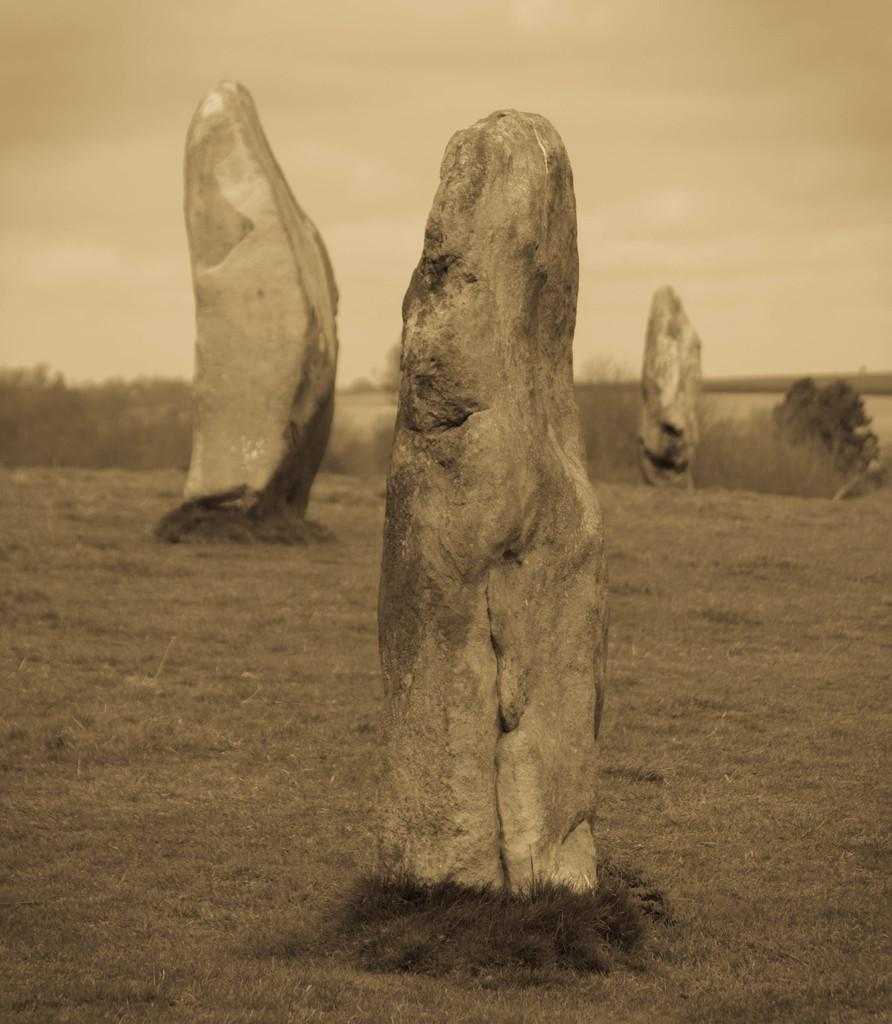What is visible in the center of the image? The sky, clouds, plants, grass, and rocks are visible in the center of the image. Can you describe the natural elements present in the center of the image? The center of the image features clouds, plants, grass, and rocks. What type of terrain is suggested by the presence of grass and rocks in the image? The presence of grass and rocks suggests a natural, outdoor terrain. What type of camp can be seen set up in the center of the image? There is no camp present in the image; it features natural elements such as the sky, clouds, plants, grass, and rocks. What tendency can be observed among the rocks in the center of the image? There is no specific tendency among the rocks that can be observed in the image. 